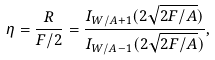<formula> <loc_0><loc_0><loc_500><loc_500>\eta = \frac { R } { F / 2 } = \frac { I _ { W / A + 1 } ( 2 \sqrt { 2 F / A } ) } { I _ { W / A - 1 } ( 2 \sqrt { 2 F / A } ) } ,</formula> 